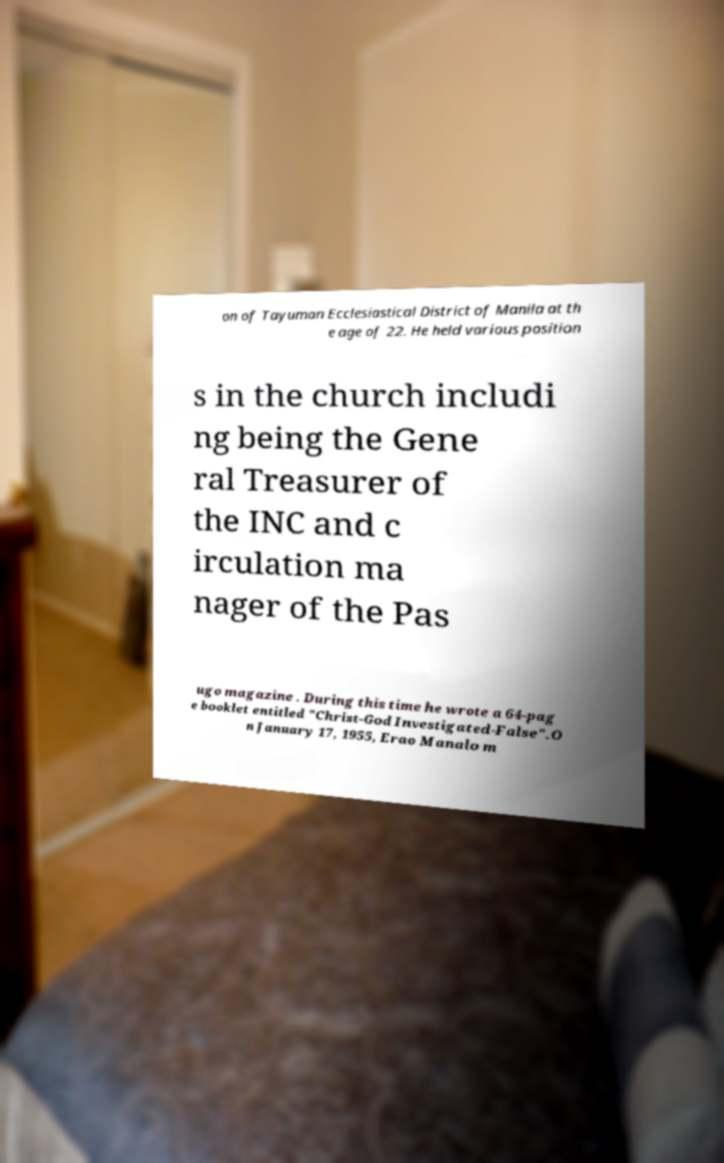Please identify and transcribe the text found in this image. on of Tayuman Ecclesiastical District of Manila at th e age of 22. He held various position s in the church includi ng being the Gene ral Treasurer of the INC and c irculation ma nager of the Pas ugo magazine . During this time he wrote a 64-pag e booklet entitled "Christ-God Investigated-False".O n January 17, 1955, Erao Manalo m 